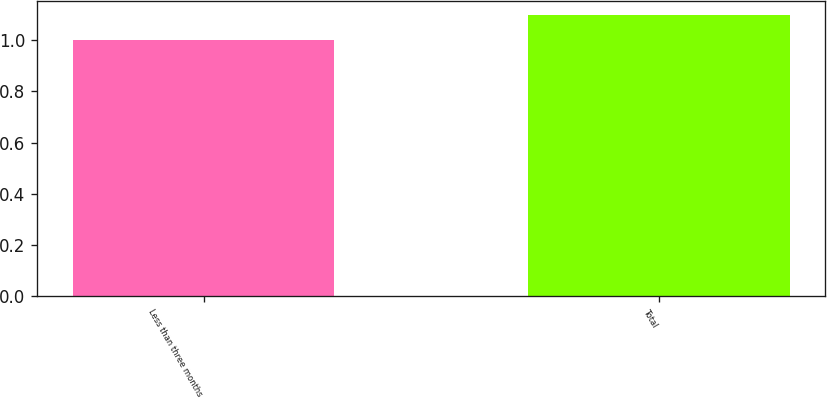Convert chart to OTSL. <chart><loc_0><loc_0><loc_500><loc_500><bar_chart><fcel>Less than three months<fcel>Total<nl><fcel>1<fcel>1.1<nl></chart> 